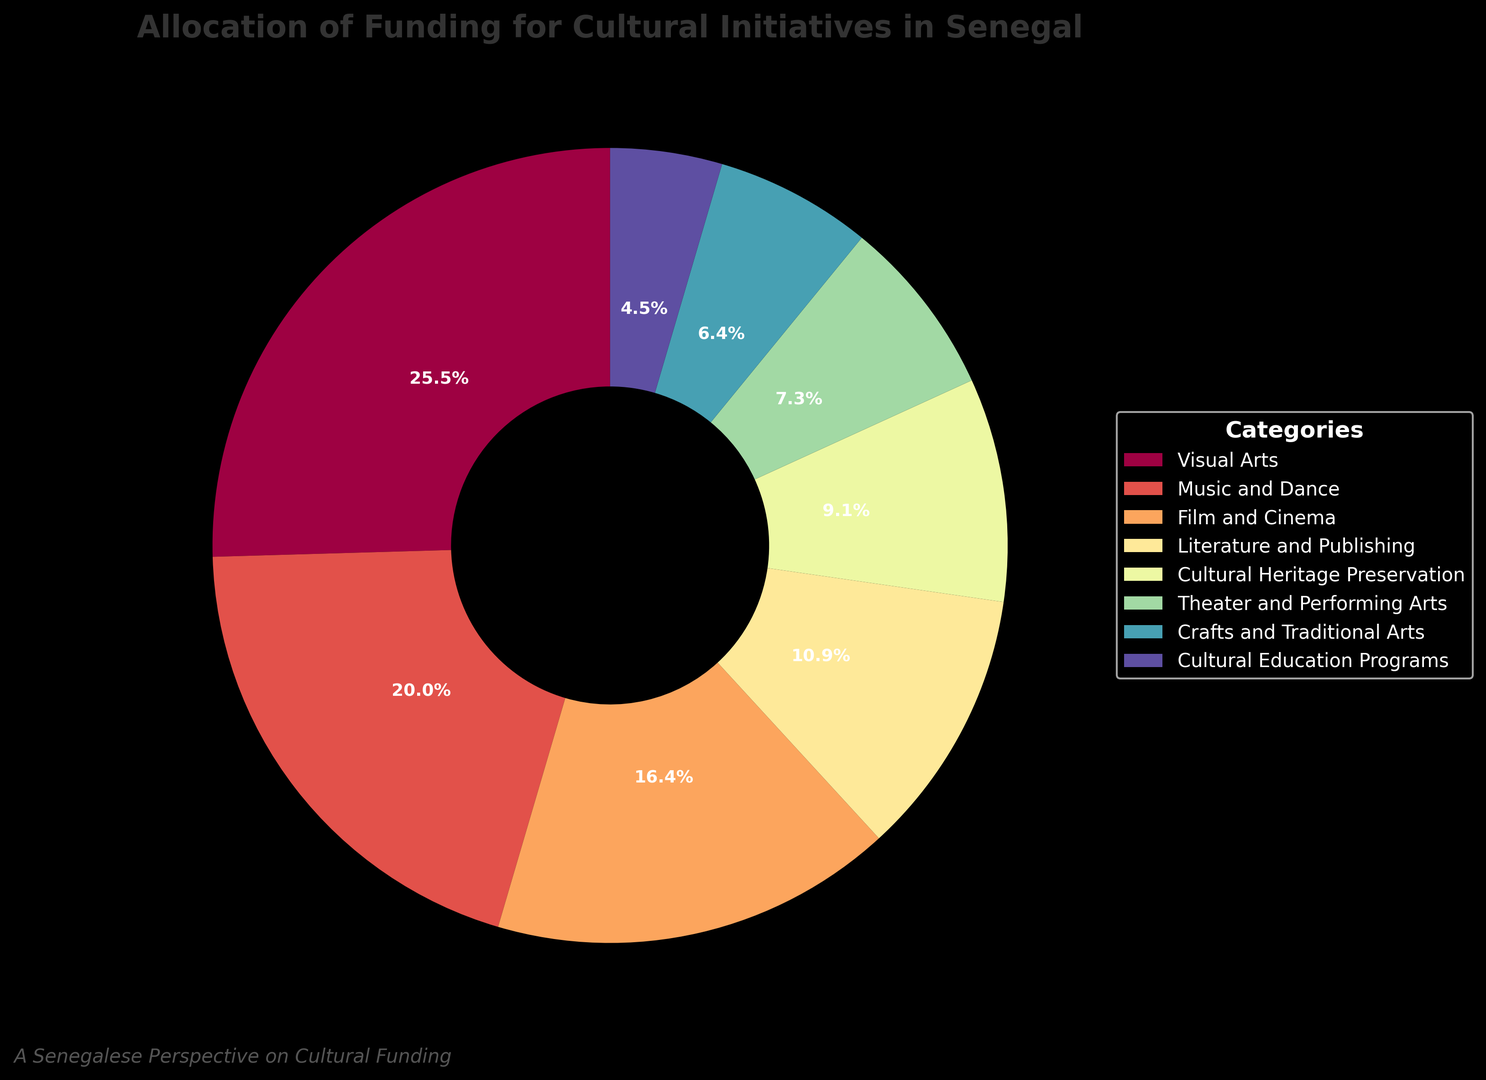How much more funding is allocated to Visual Arts compared to Theater and Performing Arts? First, identify the funding percentages for Visual Arts (28%) and Theater and Performing Arts (8%) from the pie chart. Then, subtract the smaller percentage from the larger one: 28% - 8% = 20%.
Answer: 20% Which category receives the least funding? Look at the chart and find the category with the smallest wedge size. The smallest wedge is labeled "Cultural Education Programs," which receives 5% of the funding.
Answer: Cultural Education Programs Is the funding for Music and Dance greater than the combined funding for Theater and Performing Arts and Crafts and Traditional Arts? First, find the percentages for Music and Dance (22%), Theater and Performing Arts (8%), and Crafts and Traditional Arts (7%). Then, add the percentages for Theater and Performing Arts and Crafts and Traditional Arts: 8% + 7% = 15%. Finally, compare the result with the percentage for Music and Dance: 22% > 15%.
Answer: Yes What is the total percentage of funding allocated to Film and Cinema and Literature and Publishing combined? Find the percentages for Film and Cinema (18%) and Literature and Publishing (12%). Add them together: 18% + 12% = 30%.
Answer: 30% Which category has more funding, Cultural Heritage Preservation or Crafts and Traditional Arts? Identify the funding percentages for Cultural Heritage Preservation (10%) and Crafts and Traditional Arts (7%). Compare the two values: 10% > 7%.
Answer: Cultural Heritage Preservation What is the difference in funding between the category with the highest allocation and the category with the lowest allocation? Identify the highest percentage, which is Visual Arts (28%), and the lowest percentage, which is Cultural Education Programs (5%). Subtract the lowest percentage from the highest: 28% - 5% = 23%.
Answer: 23% Are the wedges in the pie chart colored differently? Observe the pie chart and note that each wedge is colored differently. This is visually evident from the multiple unique colors representing each category.
Answer: Yes How does funding for Literature and Publishing compare to that for Music and Dance? Identify the funding percentages for Literature and Publishing (12%) and Music and Dance (22%). Compare the two values: 12% < 22%.
Answer: Less What percentage of the total funding is allocated to categories with less than 10% funding each? Identify the categories with less than 10% funding: Cultural Heritage Preservation (10%, not included), Theater and Performing Arts (8%), Crafts and Traditional Arts (7%), Cultural Education Programs (5%). Add their percentages together: 8% + 7% + 5% = 20%.
Answer: 20% Which category gets nearly a quarter of the total funding? Look at the pie chart and identify the category that receives a percentage close to 25%. Visual Arts receives 28%, which is close to a quarter.
Answer: Visual Arts 